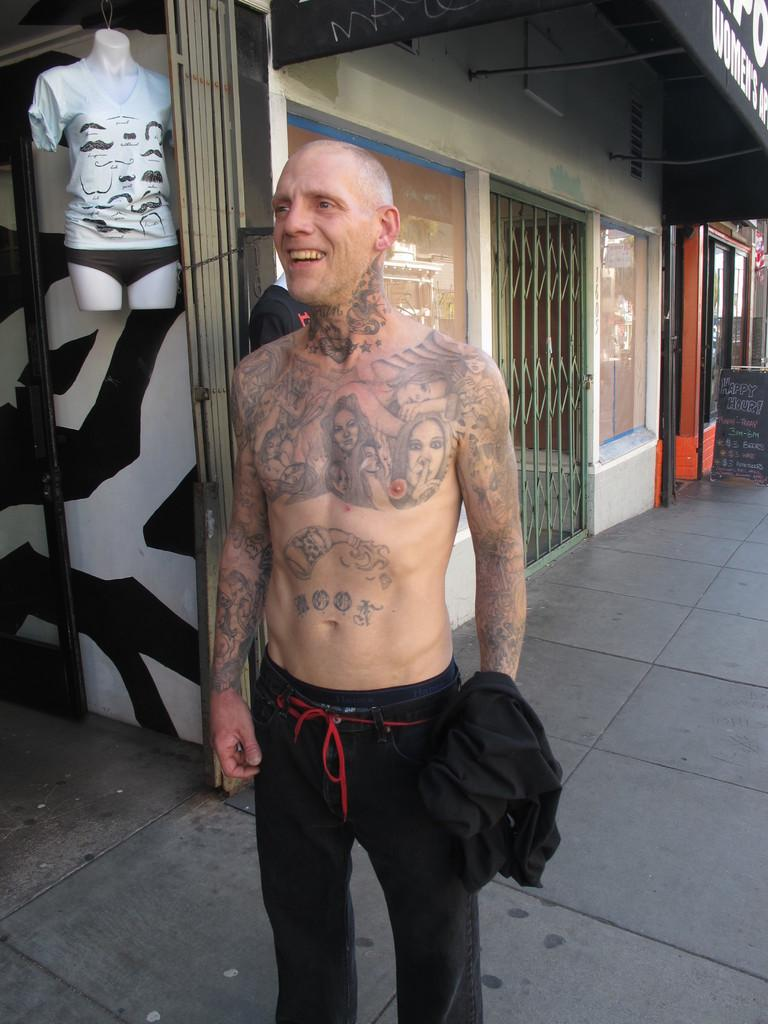Who or what is present in the image? There is a person in the image. What can be observed about the person's attire? The person is wearing clothes. What is the background of the image? The person is standing in front of a building. What else can be seen in the image? There is a display model in the top left of the image. What type of question is being asked by the dinosaurs in the image? There are no dinosaurs present in the image, so this question cannot be answered. What is the person eating for lunch in the image? There is no indication of food or lunch in the image, so it cannot be determined what the person might be eating. 